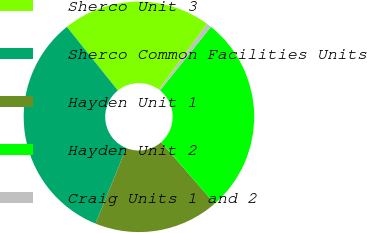<chart> <loc_0><loc_0><loc_500><loc_500><pie_chart><fcel>Sherco Unit 3<fcel>Sherco Common Facilities Units<fcel>Hayden Unit 1<fcel>Hayden Unit 2<fcel>Craig Units 1 and 2<nl><fcel>20.82%<fcel>33.1%<fcel>17.57%<fcel>27.84%<fcel>0.66%<nl></chart> 